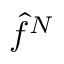Convert formula to latex. <formula><loc_0><loc_0><loc_500><loc_500>\hat { f } ^ { N }</formula> 